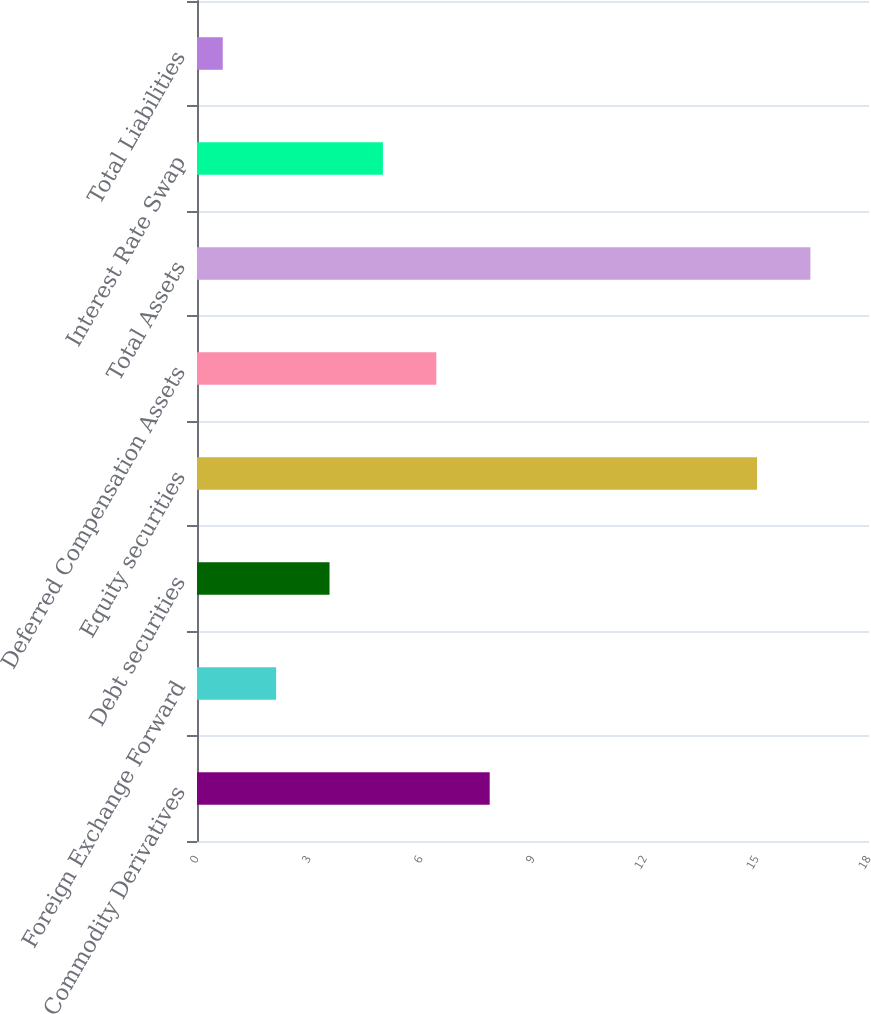<chart> <loc_0><loc_0><loc_500><loc_500><bar_chart><fcel>Commodity Derivatives<fcel>Foreign Exchange Forward<fcel>Debt securities<fcel>Equity securities<fcel>Deferred Compensation Assets<fcel>Total Assets<fcel>Interest Rate Swap<fcel>Total Liabilities<nl><fcel>7.84<fcel>2.12<fcel>3.55<fcel>15<fcel>6.41<fcel>16.43<fcel>4.98<fcel>0.69<nl></chart> 